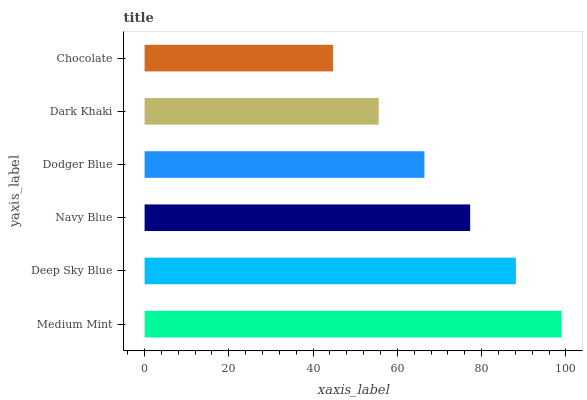Is Chocolate the minimum?
Answer yes or no. Yes. Is Medium Mint the maximum?
Answer yes or no. Yes. Is Deep Sky Blue the minimum?
Answer yes or no. No. Is Deep Sky Blue the maximum?
Answer yes or no. No. Is Medium Mint greater than Deep Sky Blue?
Answer yes or no. Yes. Is Deep Sky Blue less than Medium Mint?
Answer yes or no. Yes. Is Deep Sky Blue greater than Medium Mint?
Answer yes or no. No. Is Medium Mint less than Deep Sky Blue?
Answer yes or no. No. Is Navy Blue the high median?
Answer yes or no. Yes. Is Dodger Blue the low median?
Answer yes or no. Yes. Is Chocolate the high median?
Answer yes or no. No. Is Deep Sky Blue the low median?
Answer yes or no. No. 